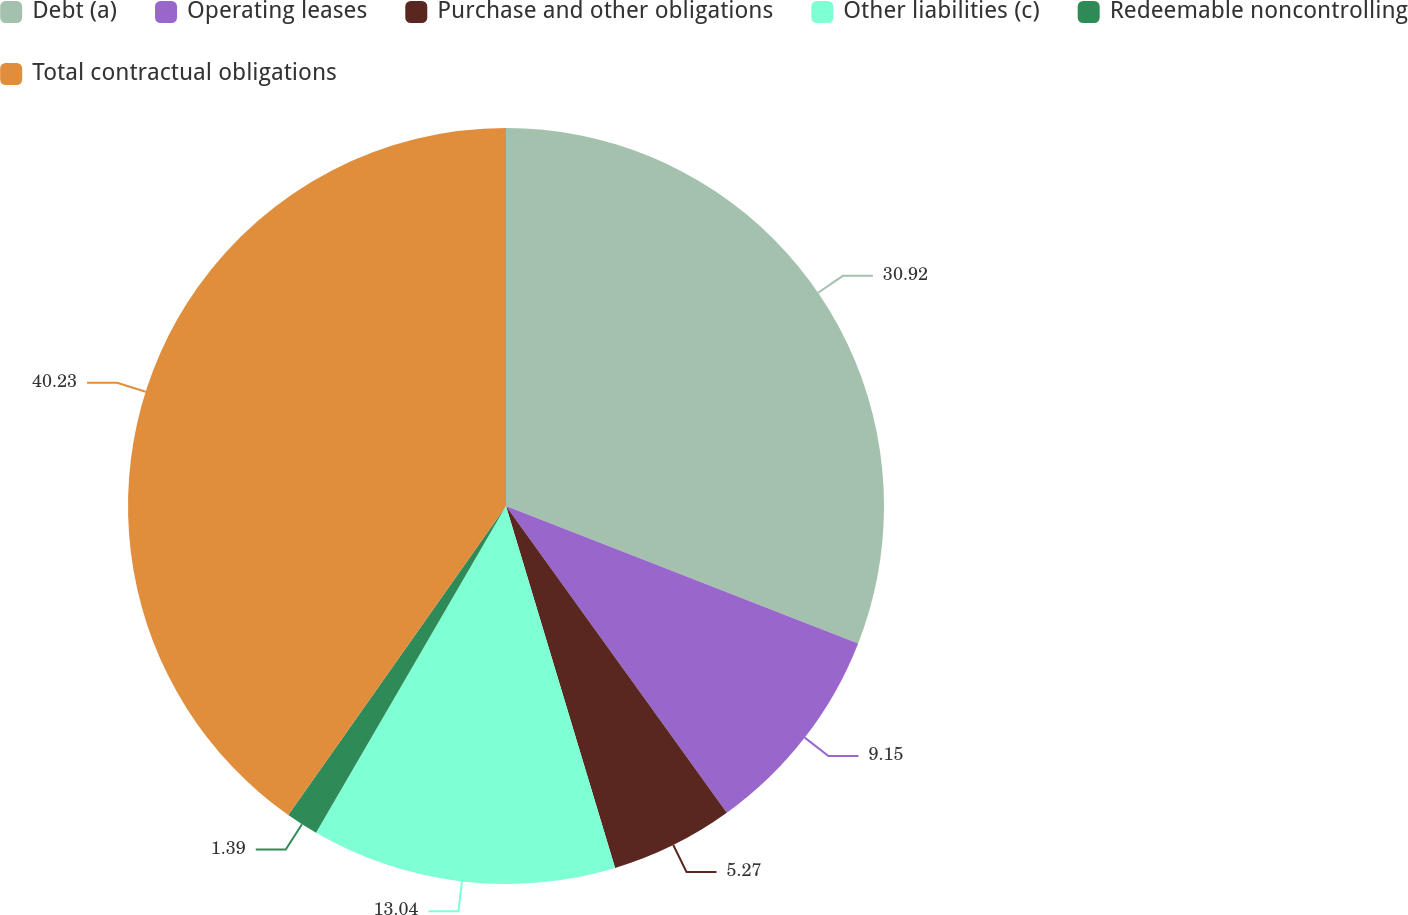Convert chart to OTSL. <chart><loc_0><loc_0><loc_500><loc_500><pie_chart><fcel>Debt (a)<fcel>Operating leases<fcel>Purchase and other obligations<fcel>Other liabilities (c)<fcel>Redeemable noncontrolling<fcel>Total contractual obligations<nl><fcel>30.92%<fcel>9.15%<fcel>5.27%<fcel>13.04%<fcel>1.39%<fcel>40.23%<nl></chart> 